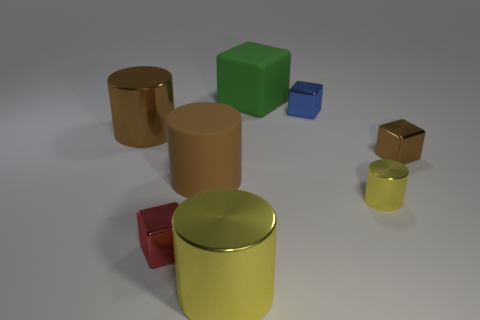Are there fewer large brown matte objects that are to the left of the large brown metal thing than brown blocks?
Your response must be concise. Yes. There is a brown metal thing to the right of the metal cylinder on the right side of the large yellow metal cylinder; are there any small red blocks that are right of it?
Ensure brevity in your answer.  No. Does the big block have the same material as the tiny blue cube that is behind the tiny red shiny thing?
Your answer should be compact. No. What is the color of the tiny thing that is to the left of the yellow shiny object that is left of the tiny blue metal object?
Offer a very short reply. Red. Are there any matte objects of the same color as the matte cylinder?
Make the answer very short. No. What is the size of the yellow thing that is right of the small metal block that is behind the brown thing that is right of the rubber cylinder?
Make the answer very short. Small. There is a small blue object; does it have the same shape as the matte object to the left of the green thing?
Give a very brief answer. No. How many other things are the same size as the red shiny block?
Your answer should be very brief. 3. What is the size of the yellow cylinder that is in front of the small red object?
Provide a succinct answer. Large. How many big red blocks are made of the same material as the tiny brown block?
Your answer should be compact. 0. 